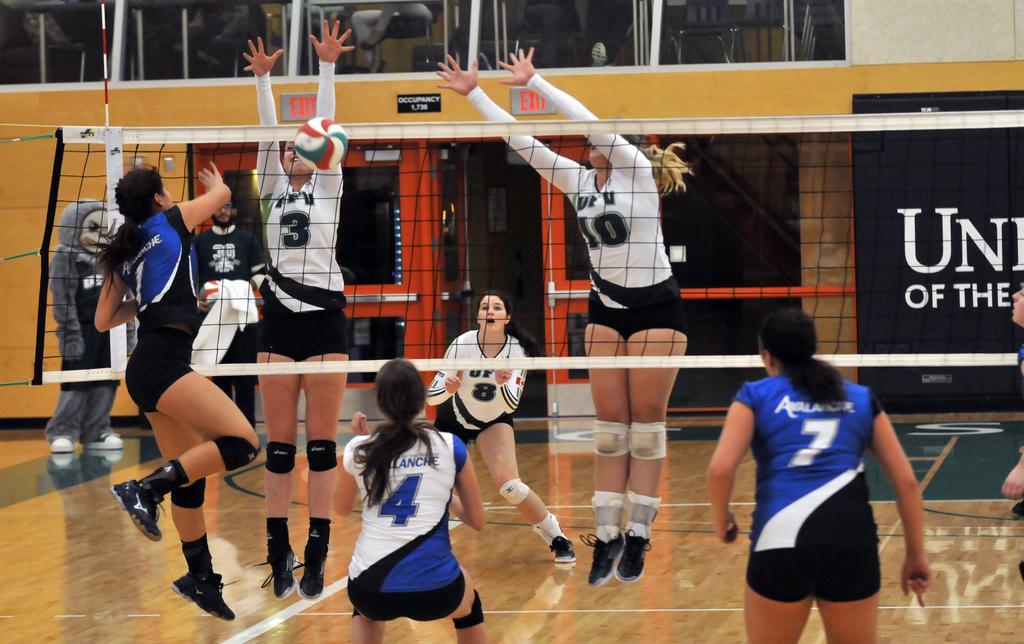How would you summarize this image in a sentence or two? In this picture I can see few women playing Volleyball and I can see a net and hoarding with some text on the back and I can see couple of them standing and a human wore mask and few people seated on the chairs on the top and it looks like a volleyball court. 